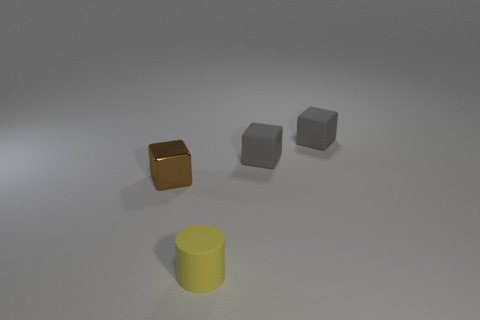Subtract all brown cylinders. Subtract all blue spheres. How many cylinders are left? 1 Add 2 metallic things. How many objects exist? 6 Subtract all cylinders. How many objects are left? 3 Subtract 0 cyan cubes. How many objects are left? 4 Subtract all tiny matte objects. Subtract all tiny brown metallic objects. How many objects are left? 0 Add 2 gray matte cubes. How many gray matte cubes are left? 4 Add 4 yellow matte things. How many yellow matte things exist? 5 